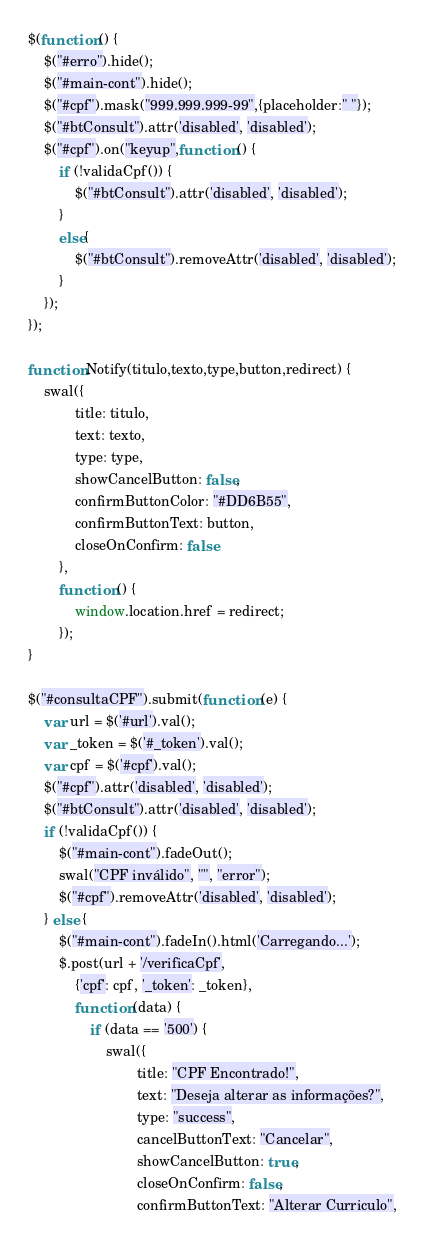<code> <loc_0><loc_0><loc_500><loc_500><_JavaScript_>$(function () {
    $("#erro").hide();
    $("#main-cont").hide();
    $("#cpf").mask("999.999.999-99",{placeholder:" "});
    $("#btConsult").attr('disabled', 'disabled');
    $("#cpf").on("keyup",function () {
        if (!validaCpf()) {
            $("#btConsult").attr('disabled', 'disabled');
        }
        else{
            $("#btConsult").removeAttr('disabled', 'disabled');
        }
    });
});

function Notify(titulo,texto,type,button,redirect) {
    swal({
            title: titulo,
            text: texto,
            type: type,
            showCancelButton: false,
            confirmButtonColor: "#DD6B55",
            confirmButtonText: button,
            closeOnConfirm: false
        },
        function () {
            window.location.href = redirect;
        });
}

$("#consultaCPF").submit(function (e) {
    var url = $('#url').val();
    var _token = $('#_token').val();
    var cpf = $('#cpf').val();
    $("#cpf").attr('disabled', 'disabled');
    $("#btConsult").attr('disabled', 'disabled');
    if (!validaCpf()) {
        $("#main-cont").fadeOut();
        swal("CPF inválido", "", "error");
        $("#cpf").removeAttr('disabled', 'disabled');
    } else {
        $("#main-cont").fadeIn().html('Carregando...');
        $.post(url + '/verificaCpf',
            {'cpf': cpf, '_token': _token},
            function (data) {
                if (data == '500') {
                    swal({
                            title: "CPF Encontrado!",
                            text: "Deseja alterar as informações?",
                            type: "success",
                            cancelButtonText: "Cancelar",
                            showCancelButton: true,
                            closeOnConfirm: false,
                            confirmButtonText: "Alterar Curriculo",</code> 